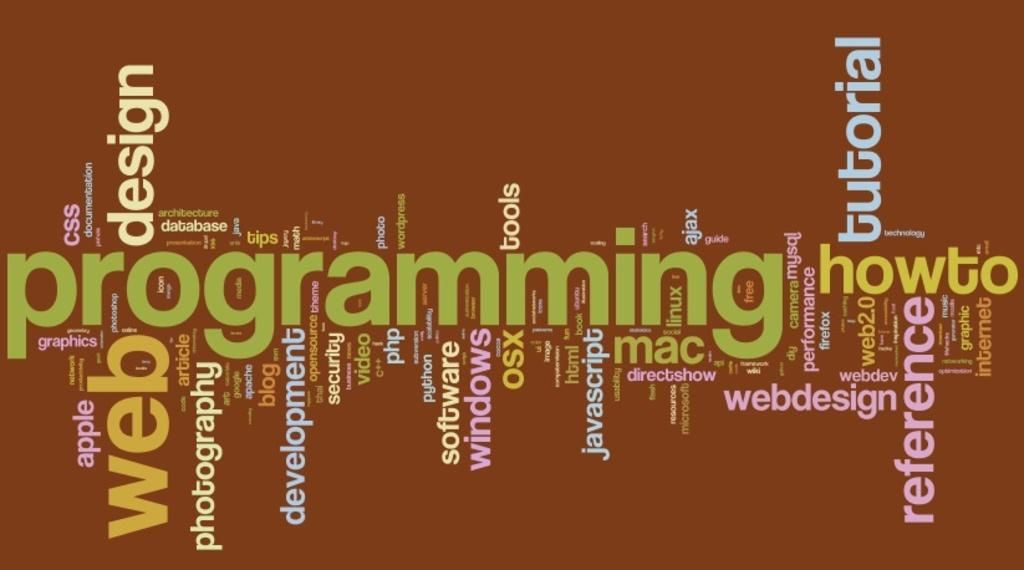<image>
Describe the image concisely. A word cloud features technology words like programming, javascript and web. 